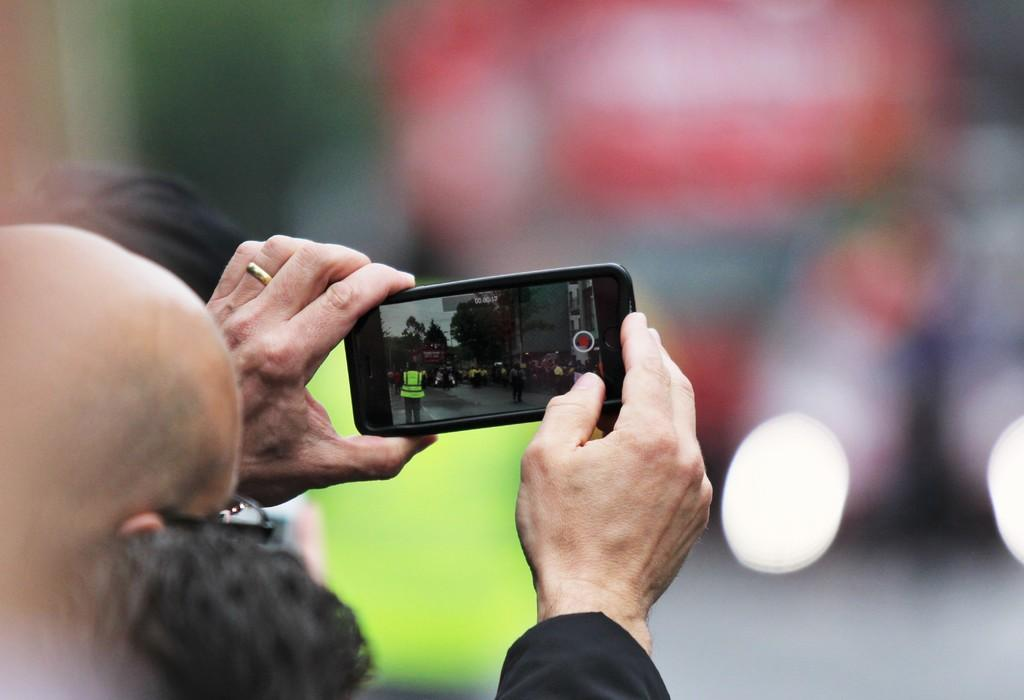What is the main subject of the image? There is a person in the image. What is the person doing in the image? The person is standing and holding a phone in his hand. What is the purpose of the phone in the image? The phone is being used to take a picture. What type of face can be seen on the crate in the image? There is no crate present in the image, and therefore no face on a crate can be observed. 